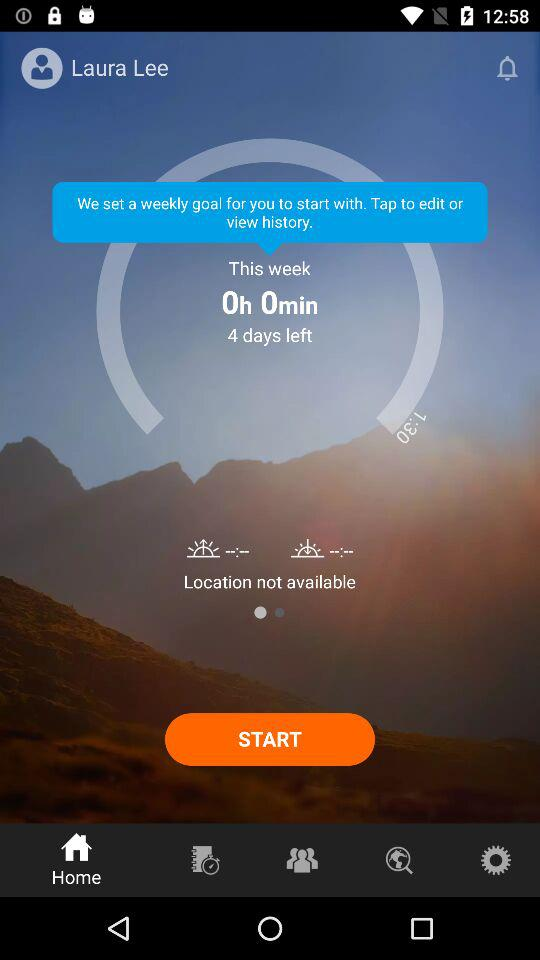How old is Laura Lee?
When the provided information is insufficient, respond with <no answer>. <no answer> 